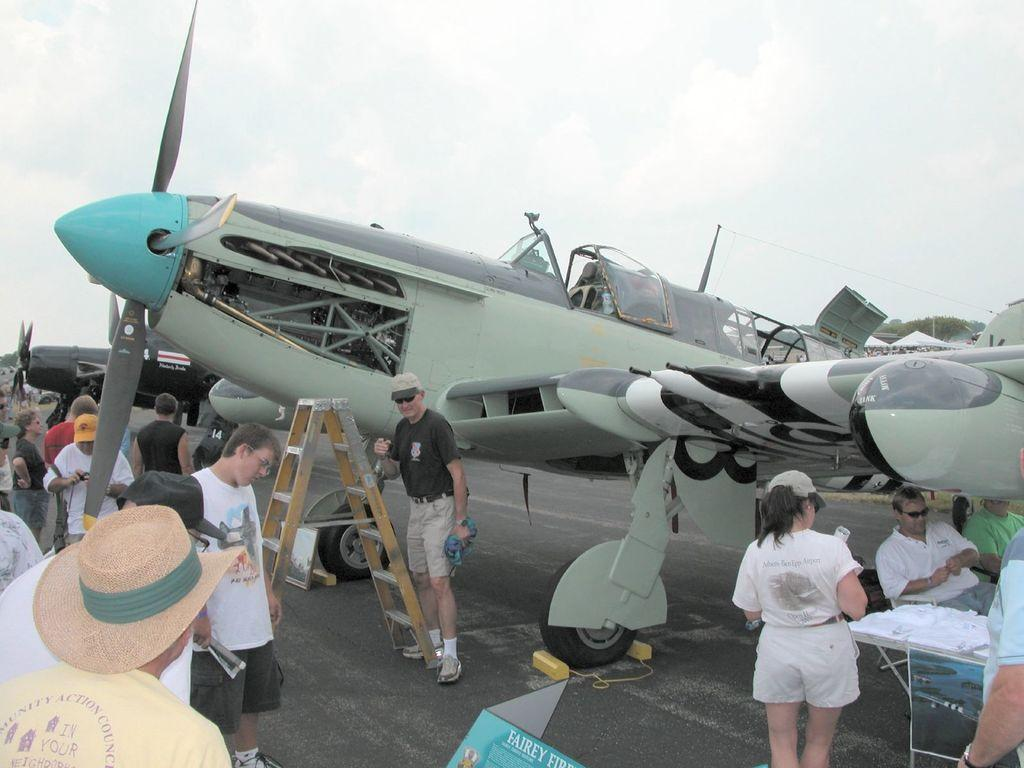What is the main subject of the image? The main subject of the image is an aircraft. What else can be seen in the image besides the aircraft? There is a ladder, people, a table, and another aircraft in the background of the image. What is the purpose of the ladder in the image? The ladder's purpose is not specified, but it could be used for boarding or maintenance of the aircraft. What is visible in the background of the image? The sky is visible in the background of the image. What type of bead is being used to design the aircraft in the image? There is no mention of beads or any design process in the image; it simply shows an aircraft and related objects. 